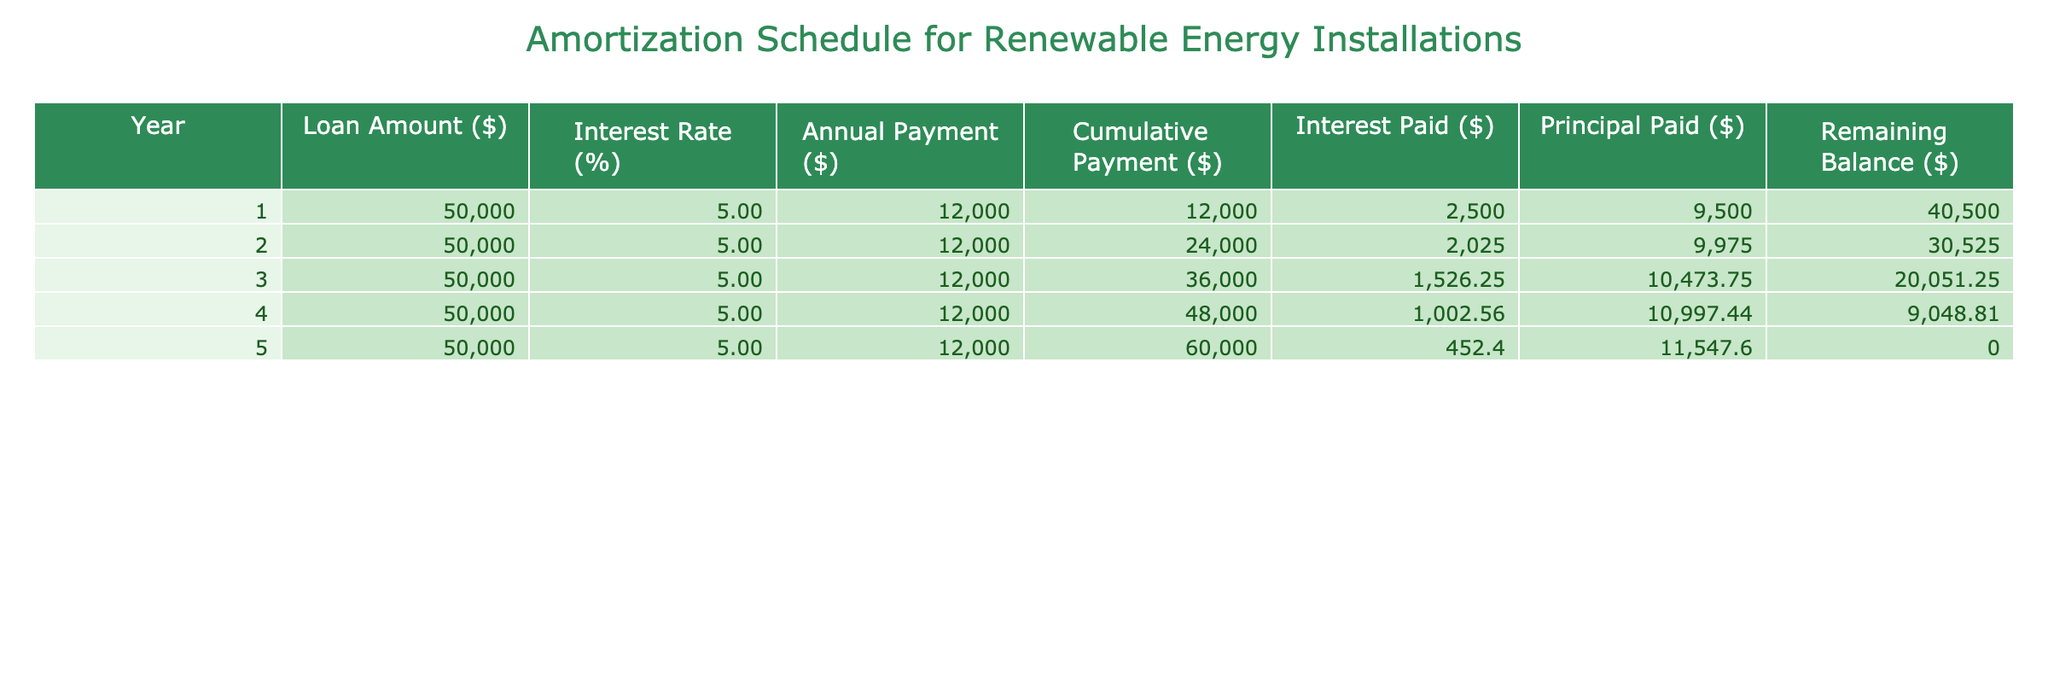What is the annual payment for the loan? The table indicates that the annual payment for the loan remains constant at $12,000 for each of the five years.
Answer: $12,000 How much total has been paid by the end of year 3? The cumulative payment by the end of year 3 is given in the table as $36,000, which is the sum of $12,000 for each of the three years.
Answer: $36,000 What is the amount of interest paid in year 2? According to the table, the interest paid in year 2 is $2,025 listed under the corresponding column for that year.
Answer: $2,025 Is the remaining balance zero at the end of the loan term? Yes, the remaining balance at the end of year 5, as shown in the table, is $0, indicating that the loan has been fully paid off.
Answer: Yes What is the total interest paid over the entire loan period? To calculate total interest, we sum the interest paid each year: $2,500 + $2,025 + $1,526.25 + $1,002.56 + $452.40 = $7,506.21.
Answer: $7,506.21 What is the average principal paid per year? The total principal paid over five years is $9,500 + $9,975 + $10,473.75 + $11,997.44 + $11,547.60 = $53,493.79. Dividing by five years gives us an average of about $10,698.76.
Answer: $10,698.76 How much principal was paid in year 4 compared to year 3? The principal paid in year 4 is $11,997.44, and in year 3 it is $10,473.75. The difference between year 4 and year 3 is $11,997.44 - $10,473.75 = $1,523.69.
Answer: $1,523.69 What percentage of the loan amount is paid as principal by the end of year 5? The total principal paid is the loan amount of $50,000, which results in a percentage of 100% at the end of year 5 showing full payment of the principal.
Answer: 100% What is the minimum annual payment required to pay off the loan in 5 years at the same interest rate? The annual payment remains at $12,000 for each year needed to fully amortize the loan as outlined in the table, following standard amortization calculations with the interest rate considered.
Answer: $12,000 